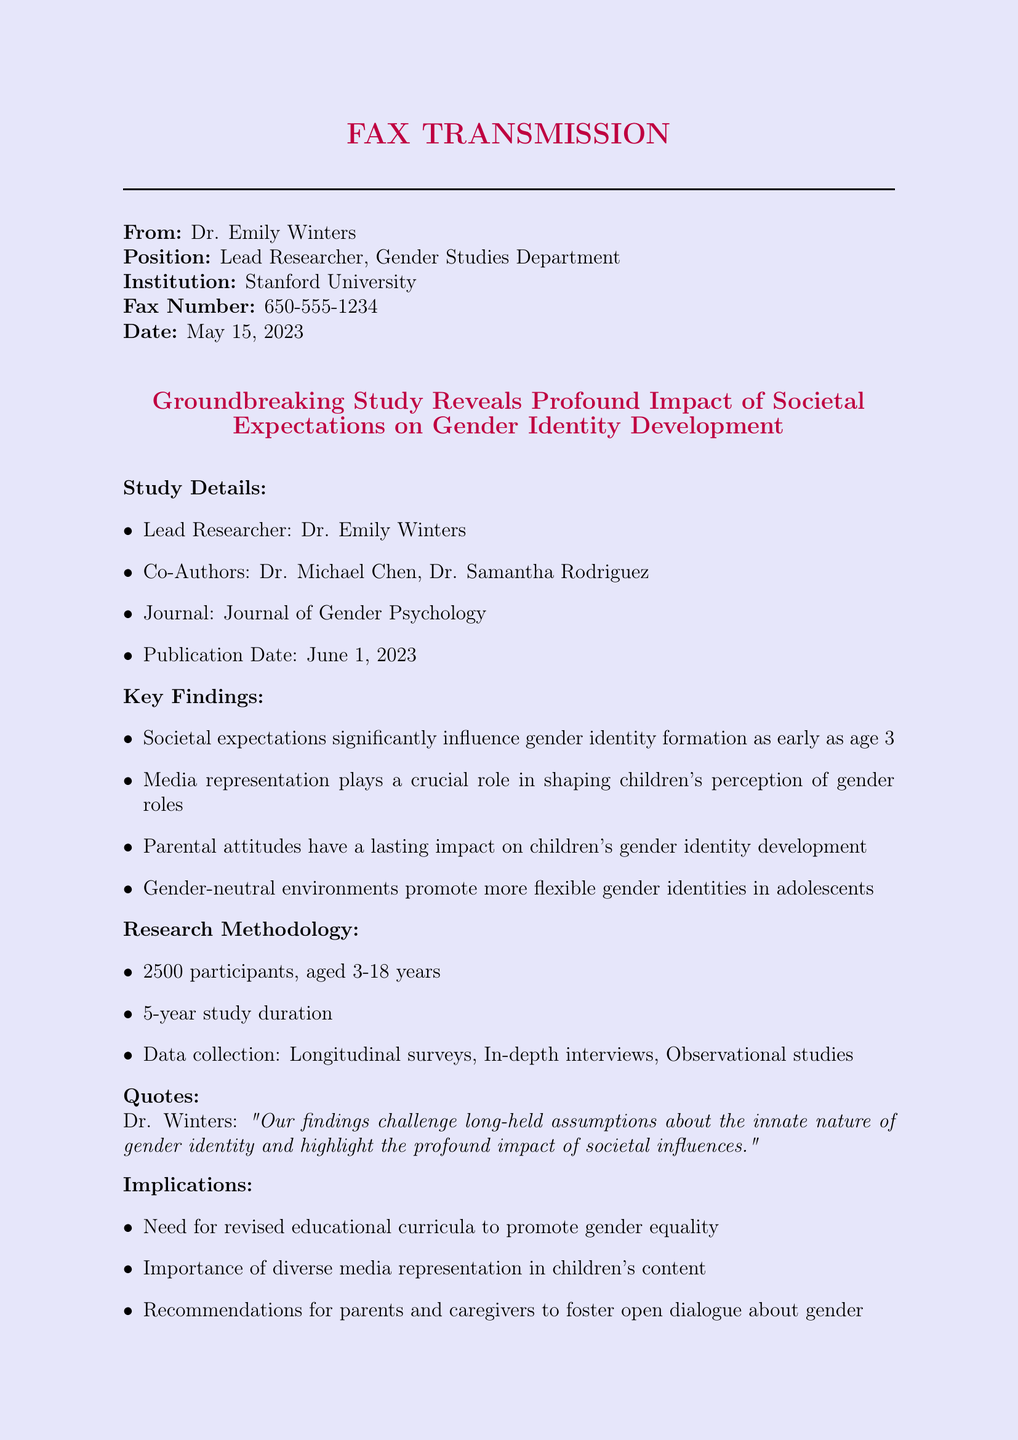What is the lead researcher's name? The lead researcher's name is mentioned in the study details section.
Answer: Dr. Emily Winters When was the press release dated? The date of the fax transmission is indicated at the beginning of the document.
Answer: May 15, 2023 How many participants were involved in the study? The number of participants is listed under the research methodology section.
Answer: 2500 participants What is the publication date of the study? The publication date is found in the study details section of the document.
Answer: June 1, 2023 What is a key finding related to media representation? The key findings list mentions the role of media representation affecting gender roles.
Answer: Crucial role in shaping children's perception of gender roles What is the importance of gender-neutral environments according to the findings? The findings state the effect of gender-neutral environments on adolescents.
Answer: Promote more flexible gender identities Who should be contacted for media inquiries? The document specifies a contact person for media inquiries at the end.
Answer: Sarah Thompson What is included in the research methodology? The research methodology section provides a brief overview of the study's approach.
Answer: Longitudinal surveys, In-depth interviews, Observational studies What significant change does the study recommend for education? The implications present recommendations based on the study's findings on education.
Answer: Revised educational curricula to promote gender equality What quote is attributed to Dr. Winters? A quote from Dr. Winters is provided in the quotes section of the document.
Answer: "Our findings challenge long-held assumptions about the innate nature of gender identity and highlight the profound impact of societal influences." 